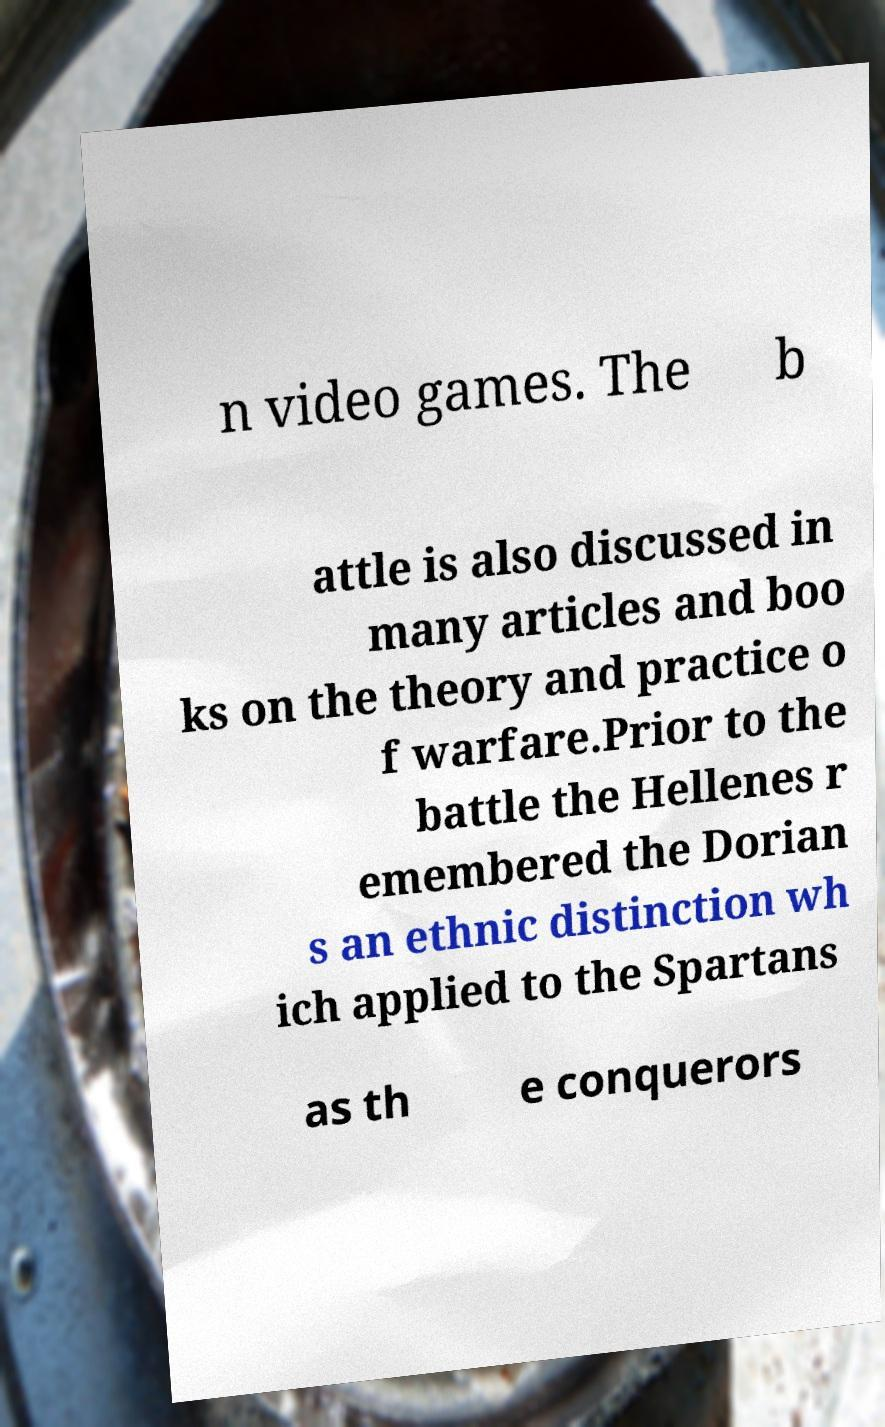I need the written content from this picture converted into text. Can you do that? n video games. The b attle is also discussed in many articles and boo ks on the theory and practice o f warfare.Prior to the battle the Hellenes r emembered the Dorian s an ethnic distinction wh ich applied to the Spartans as th e conquerors 